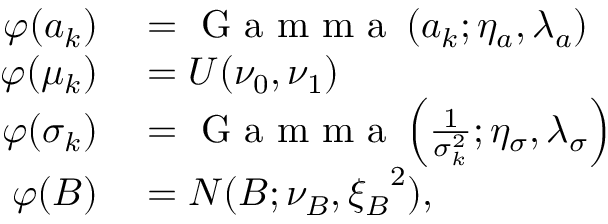Convert formula to latex. <formula><loc_0><loc_0><loc_500><loc_500>\begin{array} { r l } { \varphi ( a _ { k } ) } & = G a m m a \left ( a _ { k } ; \eta _ { a } , \lambda _ { a } \right ) } \\ { \varphi ( \mu _ { k } ) } & = U ( \nu _ { 0 } , \nu _ { 1 } ) } \\ { \varphi ( \sigma _ { k } ) } & = G a m m a \left ( \frac { 1 } { \sigma _ { k } ^ { 2 } } ; \eta _ { \sigma } , \lambda _ { \sigma } \right ) } \\ { \varphi ( B ) } & = N ( B ; \nu _ { B } , { \xi _ { B } } ^ { 2 } ) , } \end{array}</formula> 